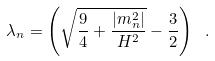<formula> <loc_0><loc_0><loc_500><loc_500>\lambda _ { n } = \left ( { \sqrt { \frac { 9 } { 4 } + \frac { | m _ { n } ^ { 2 } | } { H ^ { 2 } } } - \frac { 3 } { 2 } } \right ) \ .</formula> 